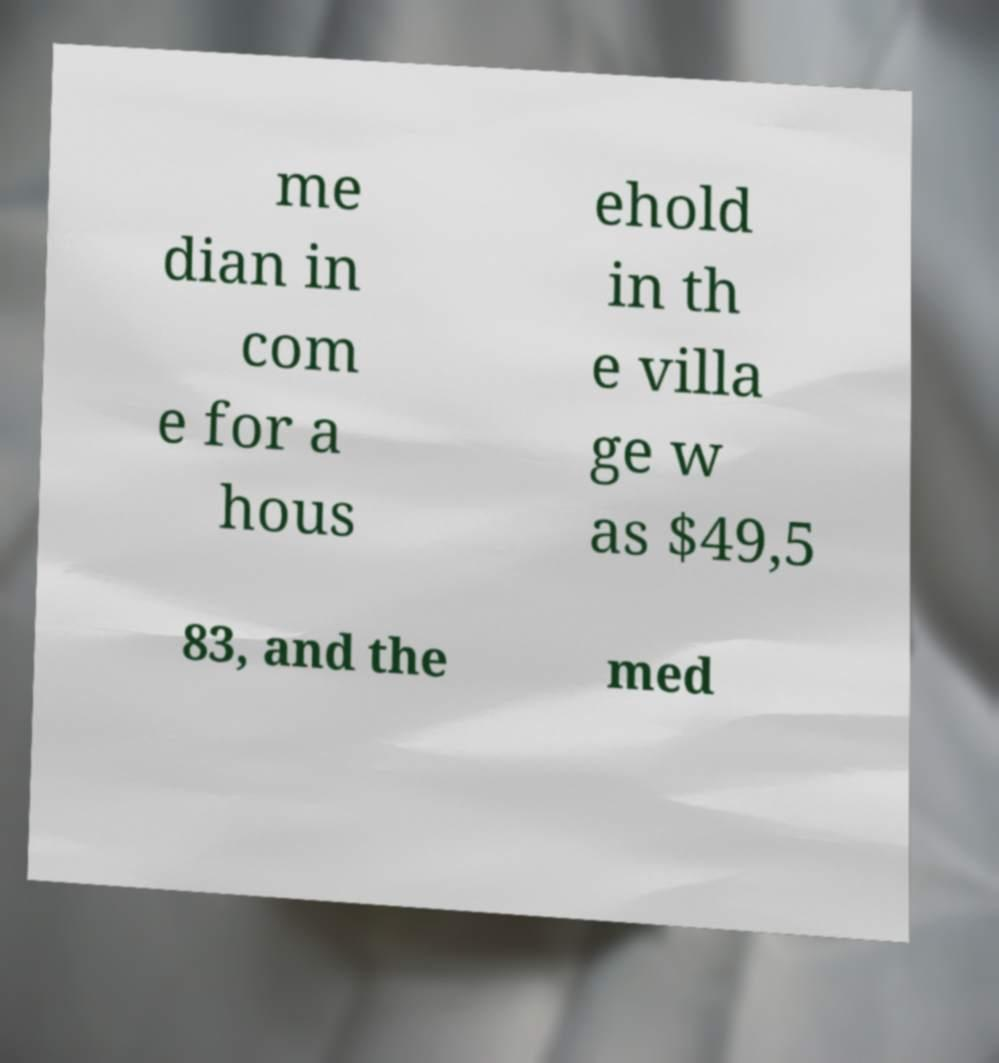There's text embedded in this image that I need extracted. Can you transcribe it verbatim? me dian in com e for a hous ehold in th e villa ge w as $49,5 83, and the med 